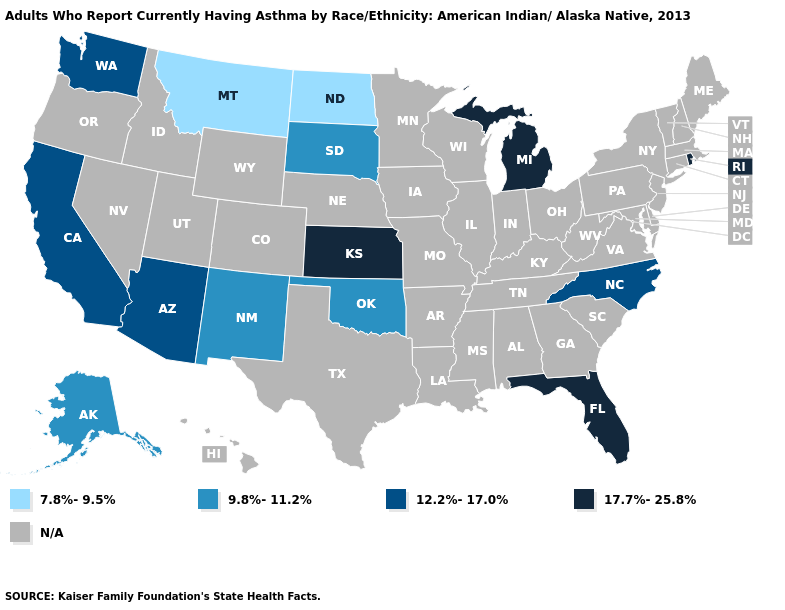What is the value of Georgia?
Answer briefly. N/A. What is the value of Ohio?
Short answer required. N/A. What is the lowest value in the USA?
Short answer required. 7.8%-9.5%. What is the value of Michigan?
Be succinct. 17.7%-25.8%. How many symbols are there in the legend?
Write a very short answer. 5. What is the value of Montana?
Write a very short answer. 7.8%-9.5%. Does the map have missing data?
Be succinct. Yes. How many symbols are there in the legend?
Give a very brief answer. 5. Name the states that have a value in the range 9.8%-11.2%?
Answer briefly. Alaska, New Mexico, Oklahoma, South Dakota. Name the states that have a value in the range 12.2%-17.0%?
Keep it brief. Arizona, California, North Carolina, Washington. Does the first symbol in the legend represent the smallest category?
Keep it brief. Yes. Does Florida have the lowest value in the USA?
Give a very brief answer. No. What is the value of Texas?
Answer briefly. N/A. 